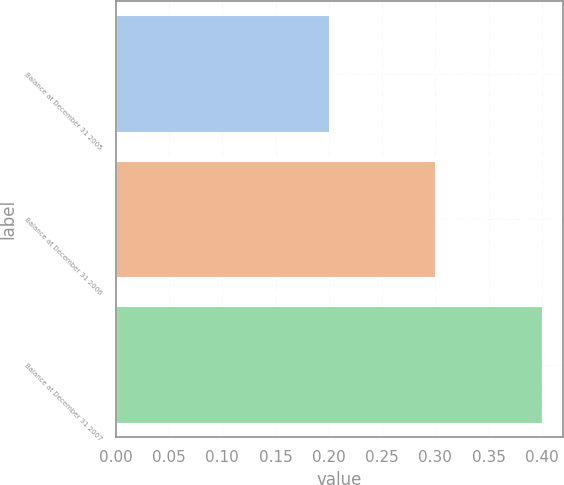<chart> <loc_0><loc_0><loc_500><loc_500><bar_chart><fcel>Balance at December 31 2005<fcel>Balance at December 31 2006<fcel>Balance at December 31 2007<nl><fcel>0.2<fcel>0.3<fcel>0.4<nl></chart> 